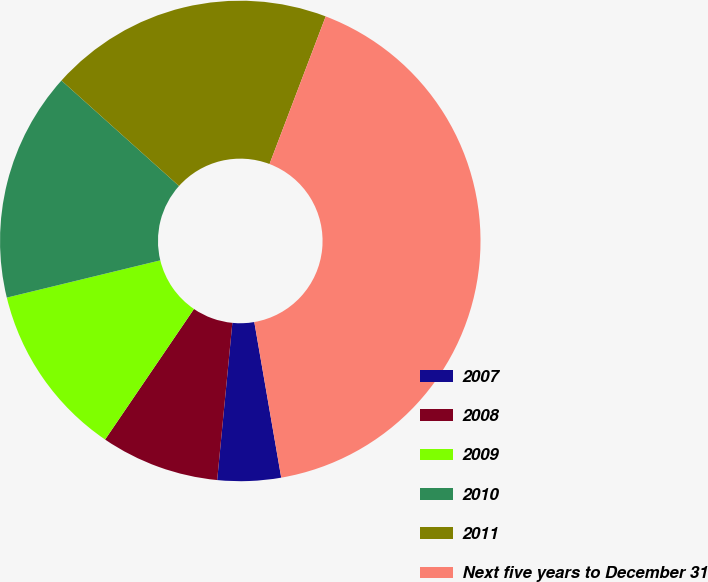<chart> <loc_0><loc_0><loc_500><loc_500><pie_chart><fcel>2007<fcel>2008<fcel>2009<fcel>2010<fcel>2011<fcel>Next five years to December 31<nl><fcel>4.26%<fcel>7.98%<fcel>11.7%<fcel>15.43%<fcel>19.15%<fcel>41.49%<nl></chart> 